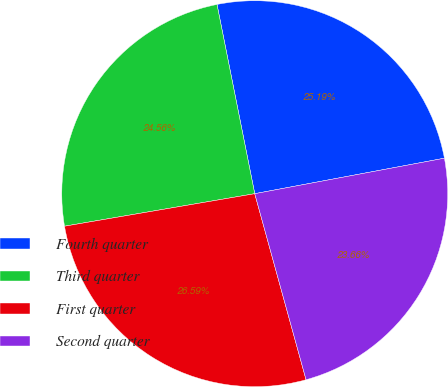<chart> <loc_0><loc_0><loc_500><loc_500><pie_chart><fcel>Fourth quarter<fcel>Third quarter<fcel>First quarter<fcel>Second quarter<nl><fcel>25.19%<fcel>24.56%<fcel>26.59%<fcel>23.66%<nl></chart> 